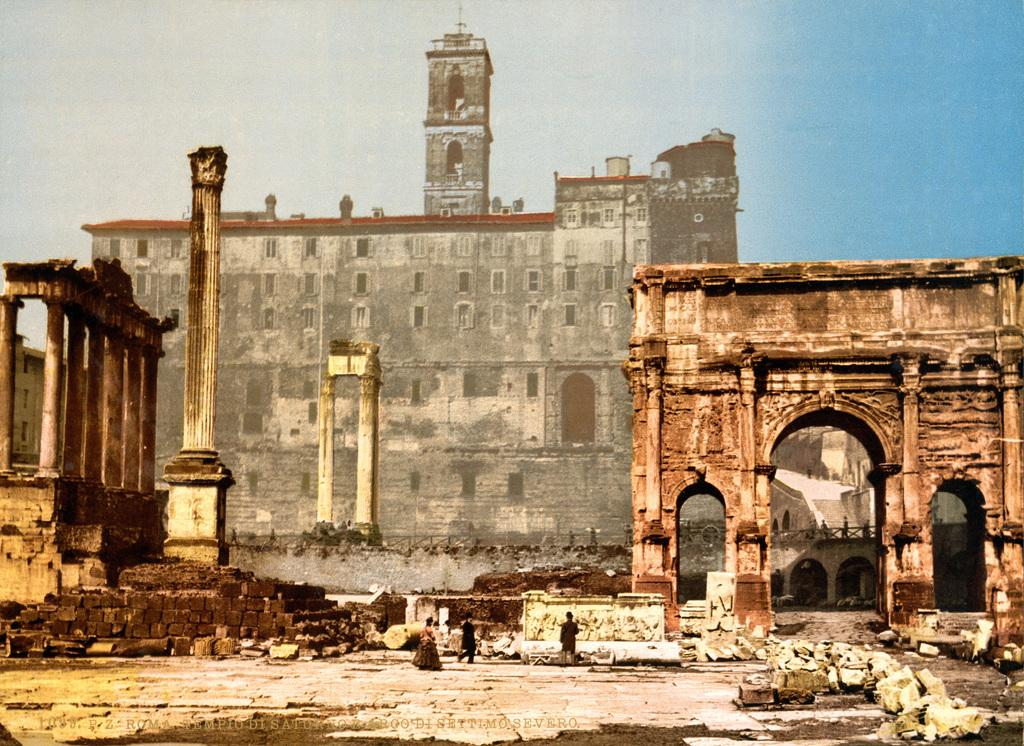What type of structures are present in the image? There are buildings in the image. What colors are the buildings? The buildings are in gray and brown colors. What are the people in the image doing? The people are walking in the image. What can be seen in the background of the image? The sky is visible in the background of the image. What colors are the sky? The sky is in blue and white colors. How do the buildings measure the distance between them in the image? The buildings do not measure the distance between them in the image; they are stationary structures. 